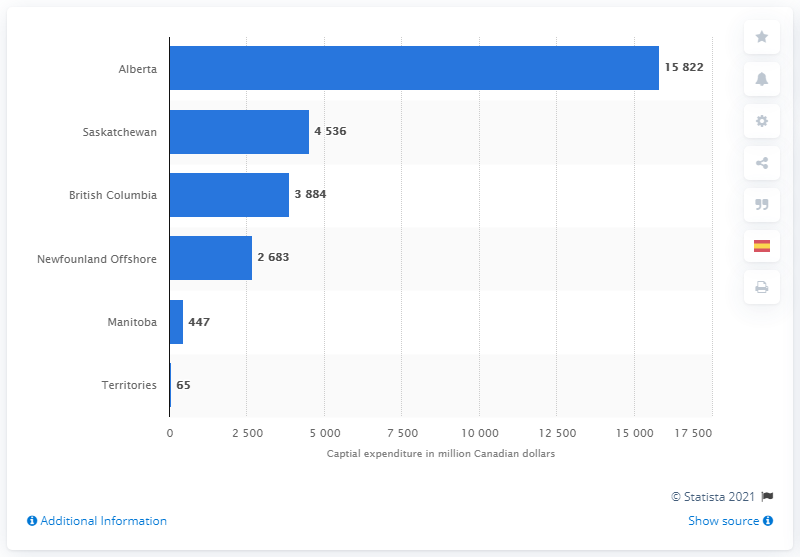List a handful of essential elements in this visual. Alberta recorded the highest amount of capital expenditures in the Canadian petroleum industry in 2018. In 2018, Alberta's capital expenditures (CAPEX) were approximately 15,822 dollars. According to the data available in 2018, the capital expenditure of Saskatchewan was approximately 4,536 dollars. 